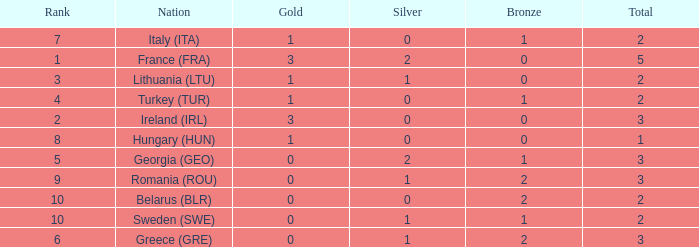What are the most bronze medals in a rank more than 1 with a total larger than 3? None. 